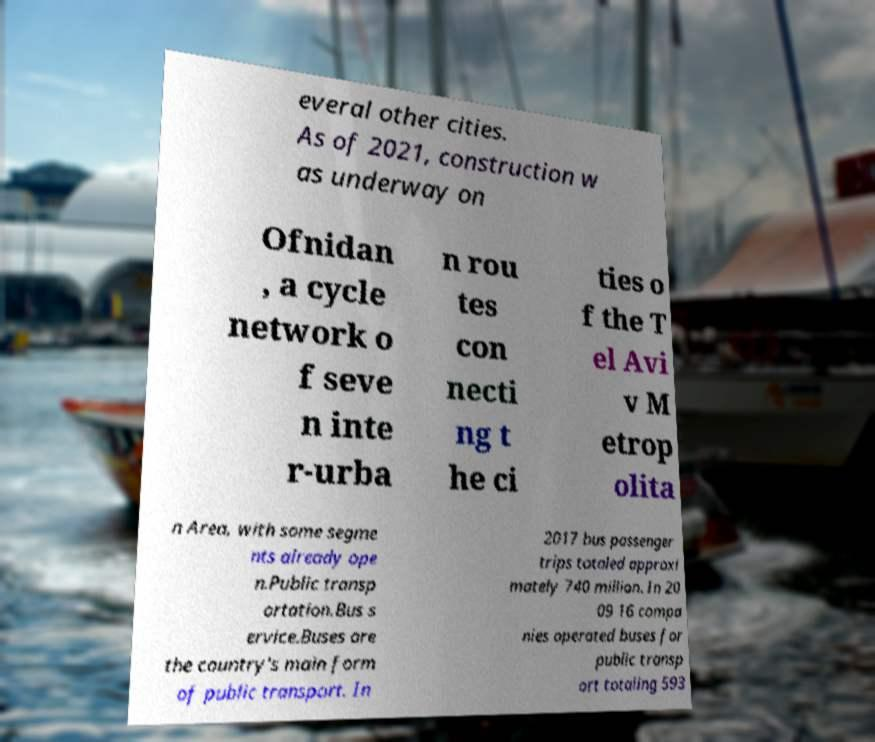For documentation purposes, I need the text within this image transcribed. Could you provide that? everal other cities. As of 2021, construction w as underway on Ofnidan , a cycle network o f seve n inte r-urba n rou tes con necti ng t he ci ties o f the T el Avi v M etrop olita n Area, with some segme nts already ope n.Public transp ortation.Bus s ervice.Buses are the country's main form of public transport. In 2017 bus passenger trips totaled approxi mately 740 million. In 20 09 16 compa nies operated buses for public transp ort totaling 593 